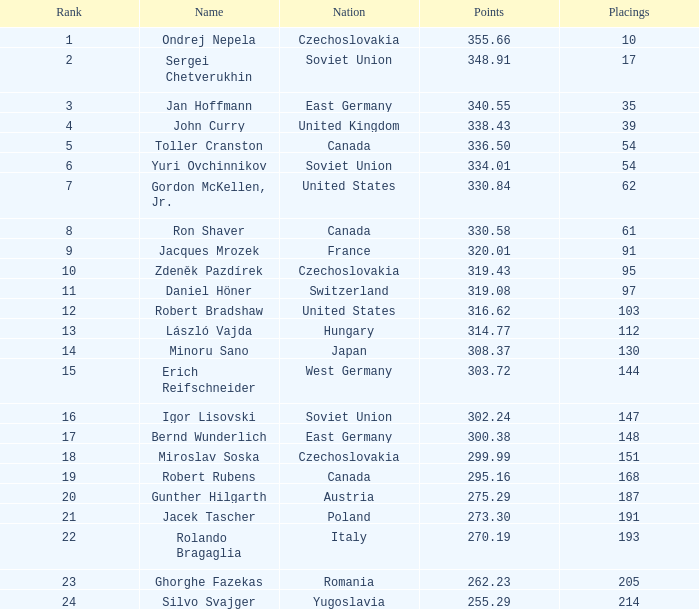Which rankings have a nation of west germany, and scores exceeding 30 None. Can you parse all the data within this table? {'header': ['Rank', 'Name', 'Nation', 'Points', 'Placings'], 'rows': [['1', 'Ondrej Nepela', 'Czechoslovakia', '355.66', '10'], ['2', 'Sergei Chetverukhin', 'Soviet Union', '348.91', '17'], ['3', 'Jan Hoffmann', 'East Germany', '340.55', '35'], ['4', 'John Curry', 'United Kingdom', '338.43', '39'], ['5', 'Toller Cranston', 'Canada', '336.50', '54'], ['6', 'Yuri Ovchinnikov', 'Soviet Union', '334.01', '54'], ['7', 'Gordon McKellen, Jr.', 'United States', '330.84', '62'], ['8', 'Ron Shaver', 'Canada', '330.58', '61'], ['9', 'Jacques Mrozek', 'France', '320.01', '91'], ['10', 'Zdeněk Pazdírek', 'Czechoslovakia', '319.43', '95'], ['11', 'Daniel Höner', 'Switzerland', '319.08', '97'], ['12', 'Robert Bradshaw', 'United States', '316.62', '103'], ['13', 'László Vajda', 'Hungary', '314.77', '112'], ['14', 'Minoru Sano', 'Japan', '308.37', '130'], ['15', 'Erich Reifschneider', 'West Germany', '303.72', '144'], ['16', 'Igor Lisovski', 'Soviet Union', '302.24', '147'], ['17', 'Bernd Wunderlich', 'East Germany', '300.38', '148'], ['18', 'Miroslav Soska', 'Czechoslovakia', '299.99', '151'], ['19', 'Robert Rubens', 'Canada', '295.16', '168'], ['20', 'Gunther Hilgarth', 'Austria', '275.29', '187'], ['21', 'Jacek Tascher', 'Poland', '273.30', '191'], ['22', 'Rolando Bragaglia', 'Italy', '270.19', '193'], ['23', 'Ghorghe Fazekas', 'Romania', '262.23', '205'], ['24', 'Silvo Svajger', 'Yugoslavia', '255.29', '214']]} 